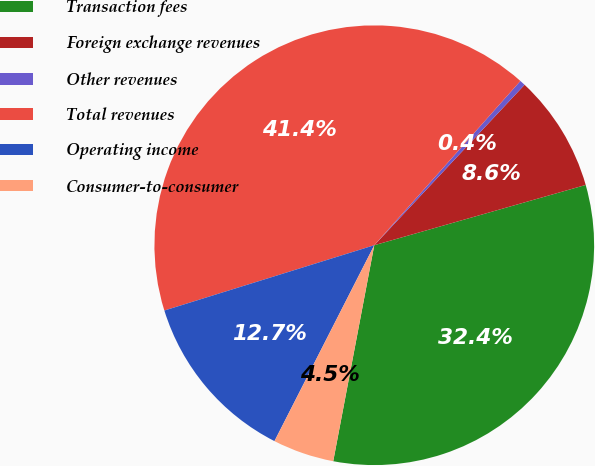<chart> <loc_0><loc_0><loc_500><loc_500><pie_chart><fcel>Transaction fees<fcel>Foreign exchange revenues<fcel>Other revenues<fcel>Total revenues<fcel>Operating income<fcel>Consumer-to-consumer<nl><fcel>32.41%<fcel>8.6%<fcel>0.41%<fcel>41.37%<fcel>12.7%<fcel>4.51%<nl></chart> 